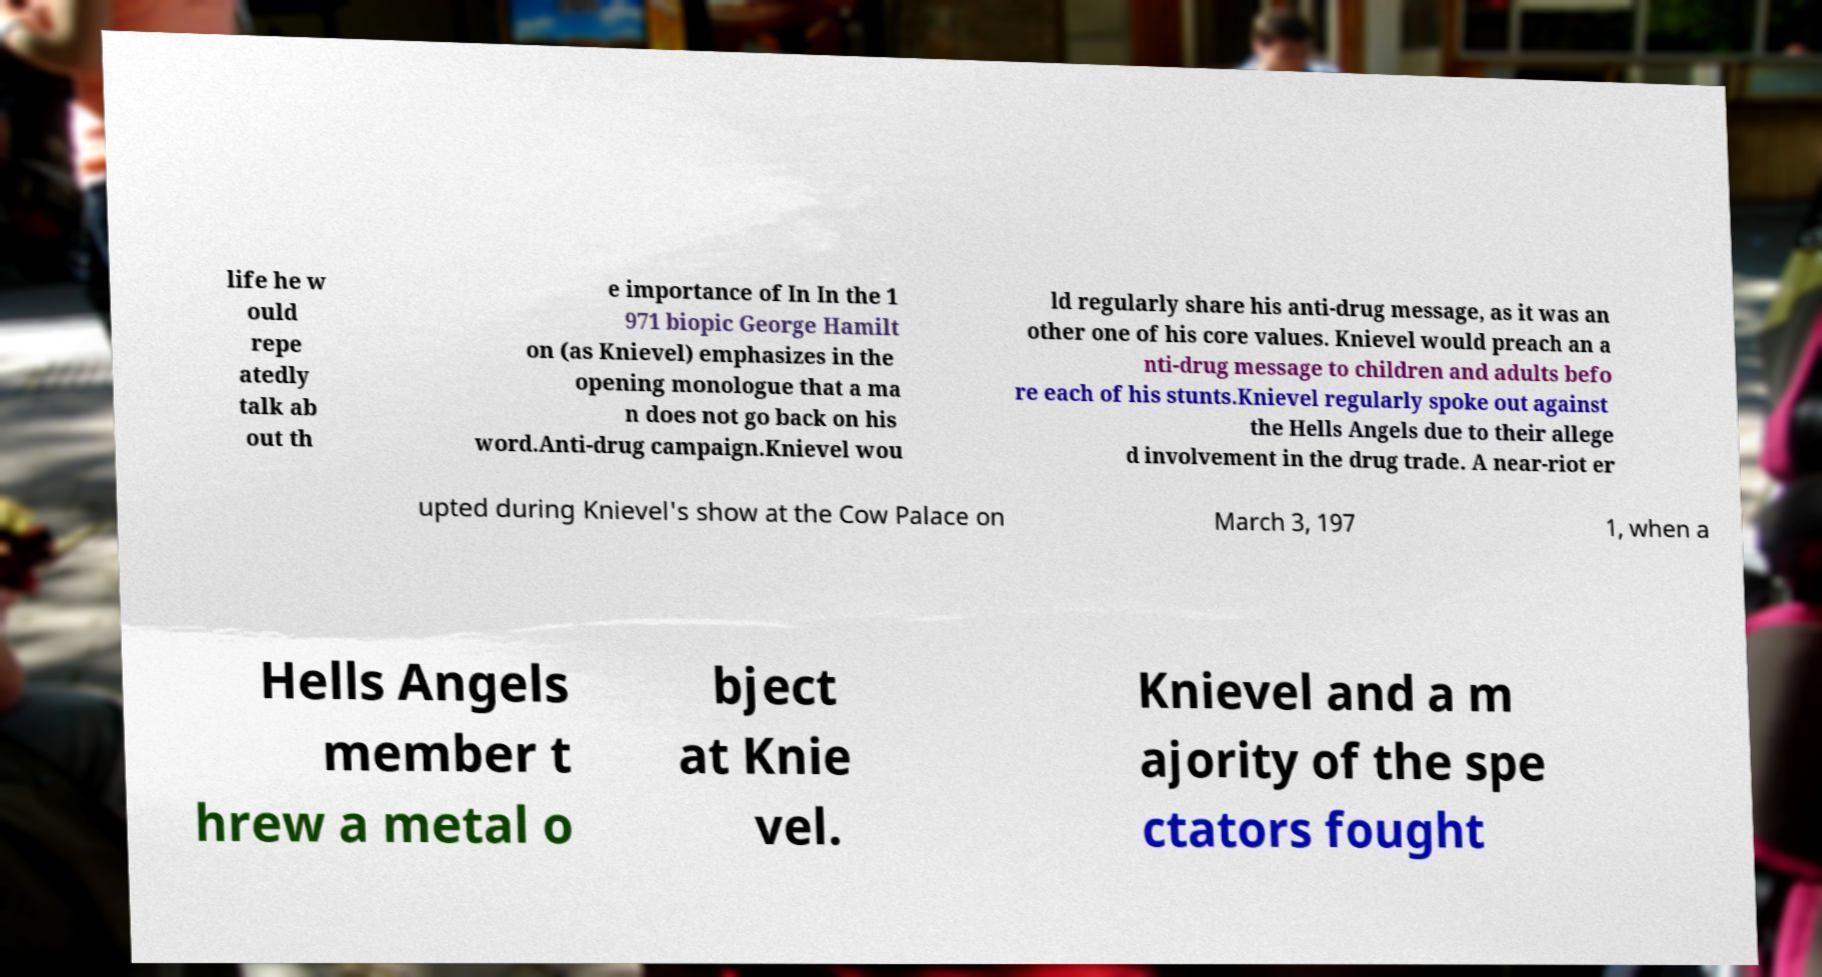I need the written content from this picture converted into text. Can you do that? life he w ould repe atedly talk ab out th e importance of In In the 1 971 biopic George Hamilt on (as Knievel) emphasizes in the opening monologue that a ma n does not go back on his word.Anti-drug campaign.Knievel wou ld regularly share his anti-drug message, as it was an other one of his core values. Knievel would preach an a nti-drug message to children and adults befo re each of his stunts.Knievel regularly spoke out against the Hells Angels due to their allege d involvement in the drug trade. A near-riot er upted during Knievel's show at the Cow Palace on March 3, 197 1, when a Hells Angels member t hrew a metal o bject at Knie vel. Knievel and a m ajority of the spe ctators fought 